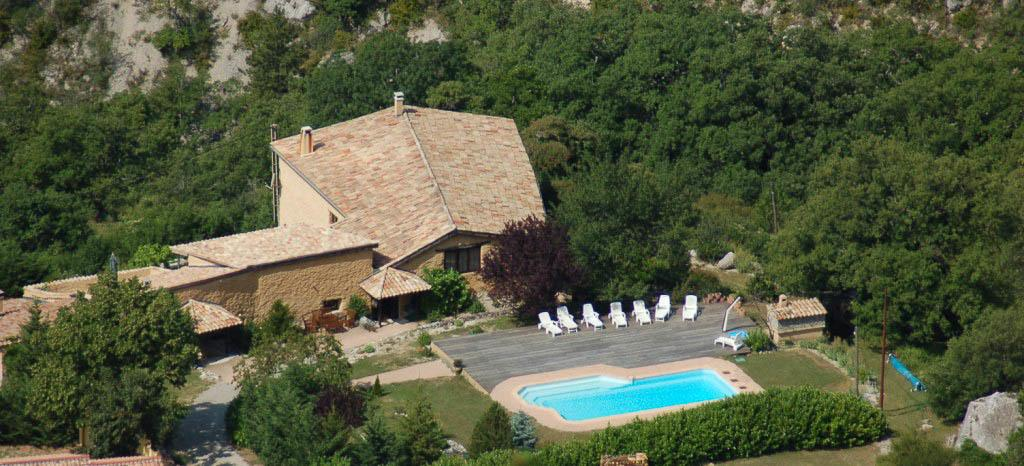What type of structure is visible in the image? There is a building in the image. What feature of the building is mentioned in the facts? There is a window in the building. What type of furniture is present in the image? There are rest chairs in the image. What color are the rest chairs? The rest chairs are white in color. What recreational area is visible in the image? There is a swimming pool in the image. What natural elements can be seen in the image? There are many trees and grass in the image. What man-made structures are present in the image? There are poles and a path in the image. How many noses can be seen on the trees in the image? There are no noses present on the trees in the image, as trees do not have noses. What is the size of the swimming pool in the image? The size of the swimming pool cannot be determined from the image alone, as there is no scale provided. 